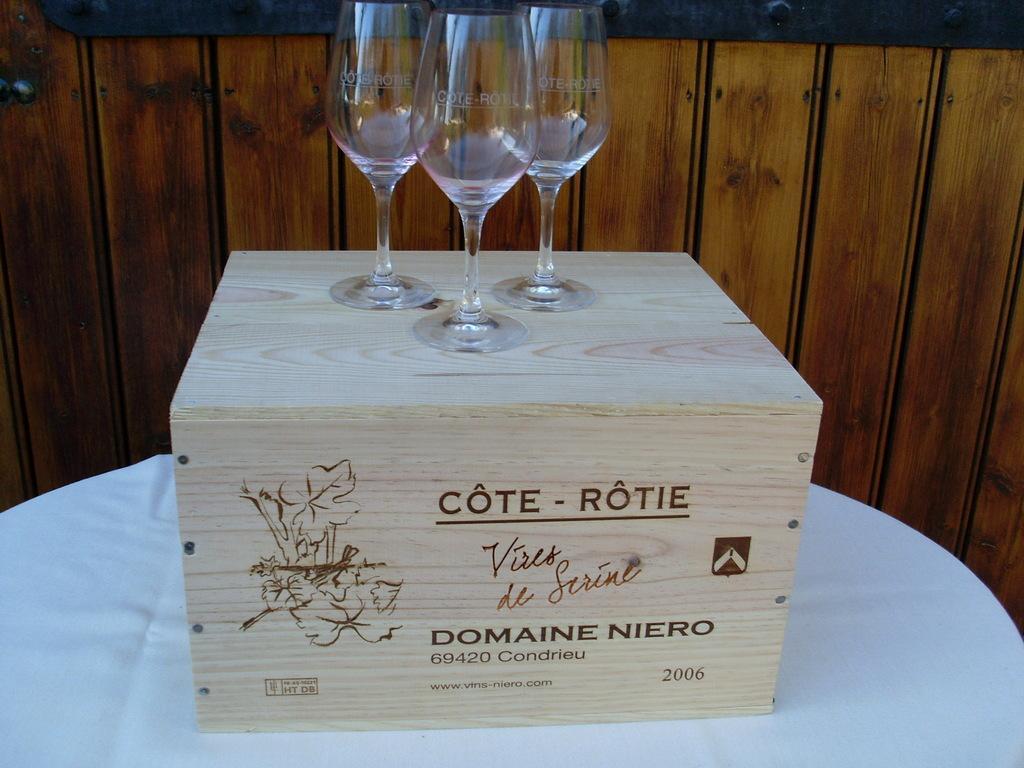In one or two sentences, can you explain what this image depicts? In this image we can see a white surface. On that there is a wooden box with text and drawing. On the box there are three glasses. In the background there is a wooden wall. 